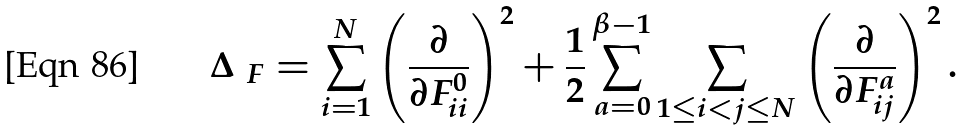<formula> <loc_0><loc_0><loc_500><loc_500>\Delta _ { \ F } = \sum _ { i = 1 } ^ { N } \left ( \frac { \partial } { \partial { F ^ { 0 } _ { i i } } } \right ) ^ { 2 } + \frac { 1 } { 2 } \sum _ { a = 0 } ^ { \beta - 1 } \sum _ { 1 \leq i < j \leq N } \left ( \frac { \partial } { \partial { F ^ { a } _ { i j } } } \right ) ^ { 2 } .</formula> 